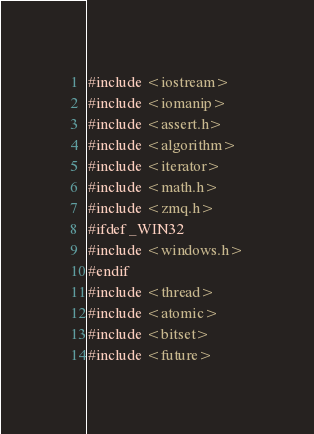Convert code to text. <code><loc_0><loc_0><loc_500><loc_500><_Cuda_>#include <iostream>
#include <iomanip>
#include <assert.h>
#include <algorithm>
#include <iterator>
#include <math.h>
#include <zmq.h>
#ifdef _WIN32
#include <windows.h>
#endif
#include <thread>
#include <atomic>
#include <bitset>
#include <future></code> 